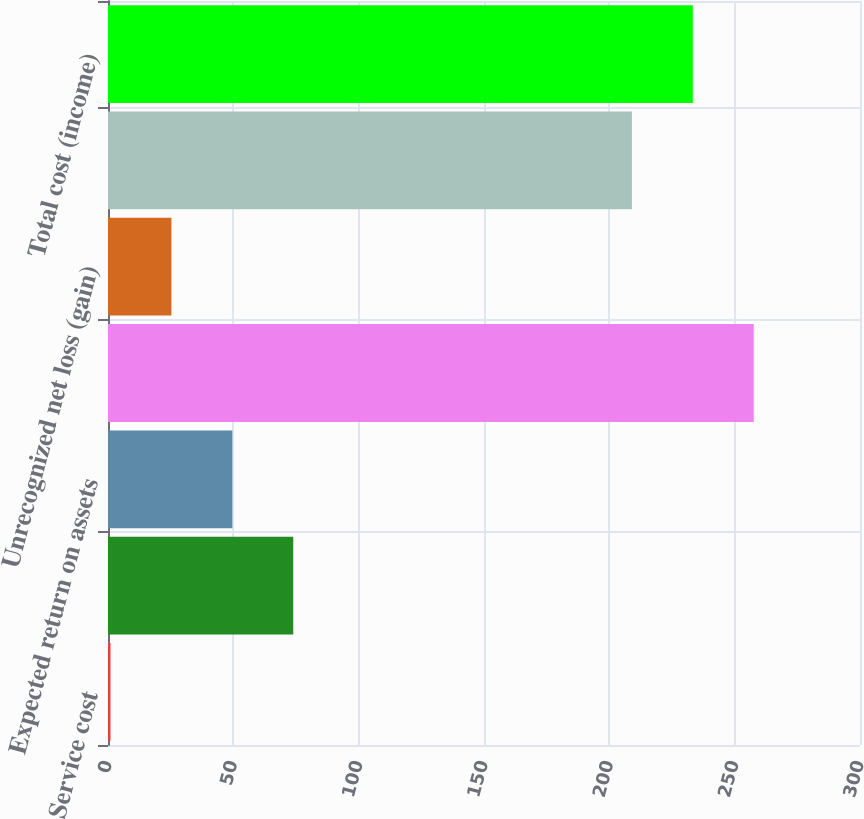Convert chart. <chart><loc_0><loc_0><loc_500><loc_500><bar_chart><fcel>Service cost<fcel>Interest cost<fcel>Expected return on assets<fcel>Prior service cost (benefit)<fcel>Unrecognized net loss (gain)<fcel>Net periodic benefit cost<fcel>Total cost (income)<nl><fcel>1<fcel>73.9<fcel>49.6<fcel>257.6<fcel>25.3<fcel>209<fcel>233.3<nl></chart> 